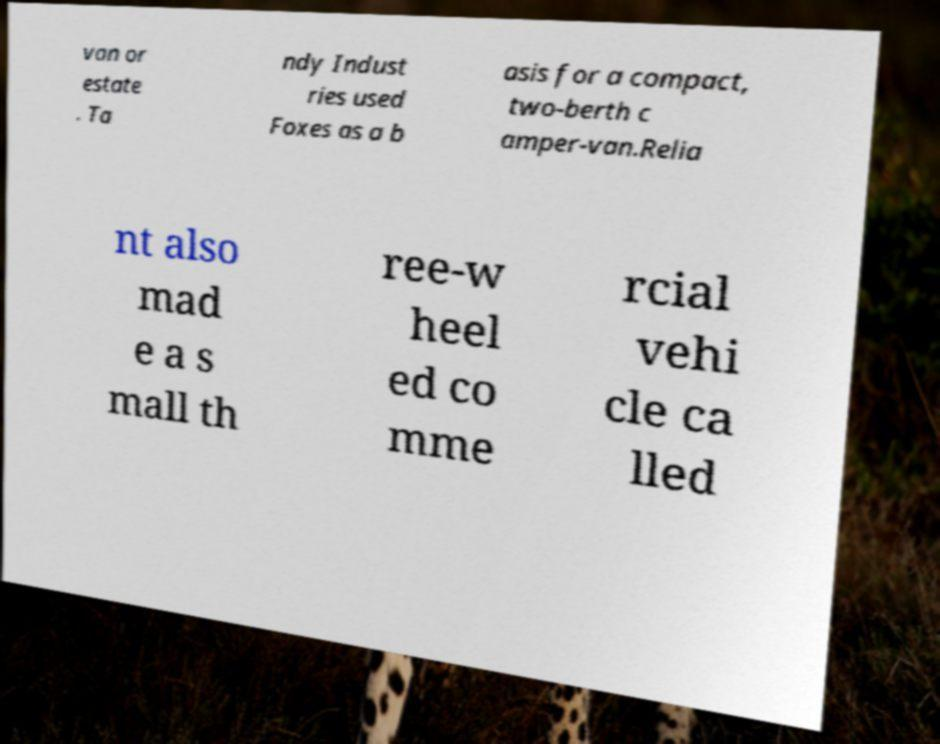Can you read and provide the text displayed in the image?This photo seems to have some interesting text. Can you extract and type it out for me? van or estate . Ta ndy Indust ries used Foxes as a b asis for a compact, two-berth c amper-van.Relia nt also mad e a s mall th ree-w heel ed co mme rcial vehi cle ca lled 